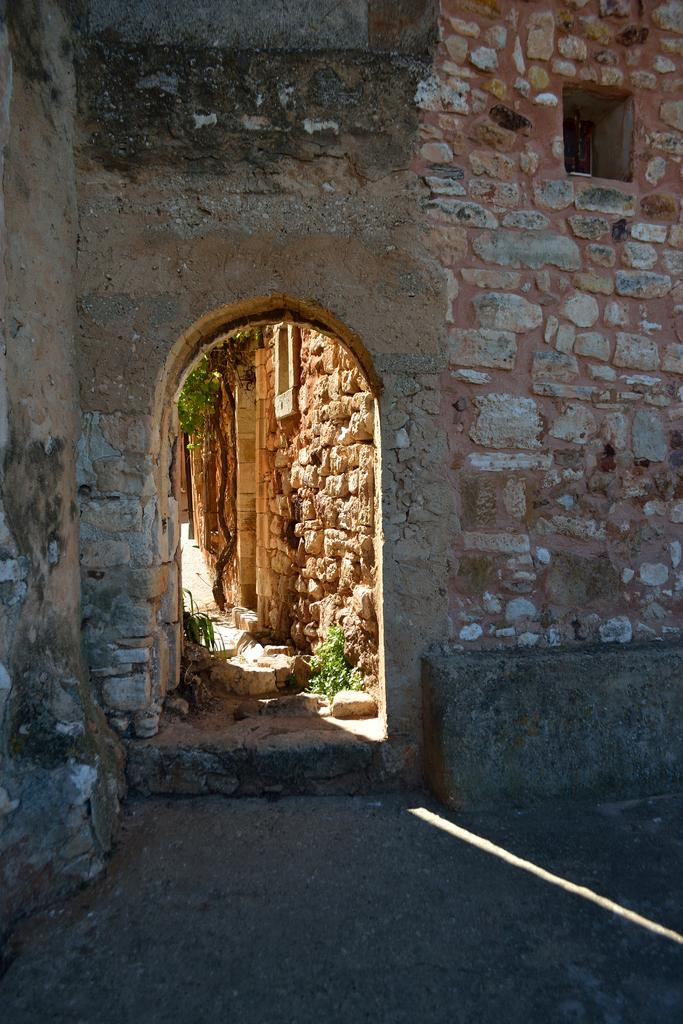What is the main subject of the picture? The main subject of the picture is a way. What can be seen in the background of the picture? There is a brick wall in the background of the picture. How many legs are visible in the image? There are no legs visible in the image. What type of metal object can be seen in the image? There is no metal object present in the image. 